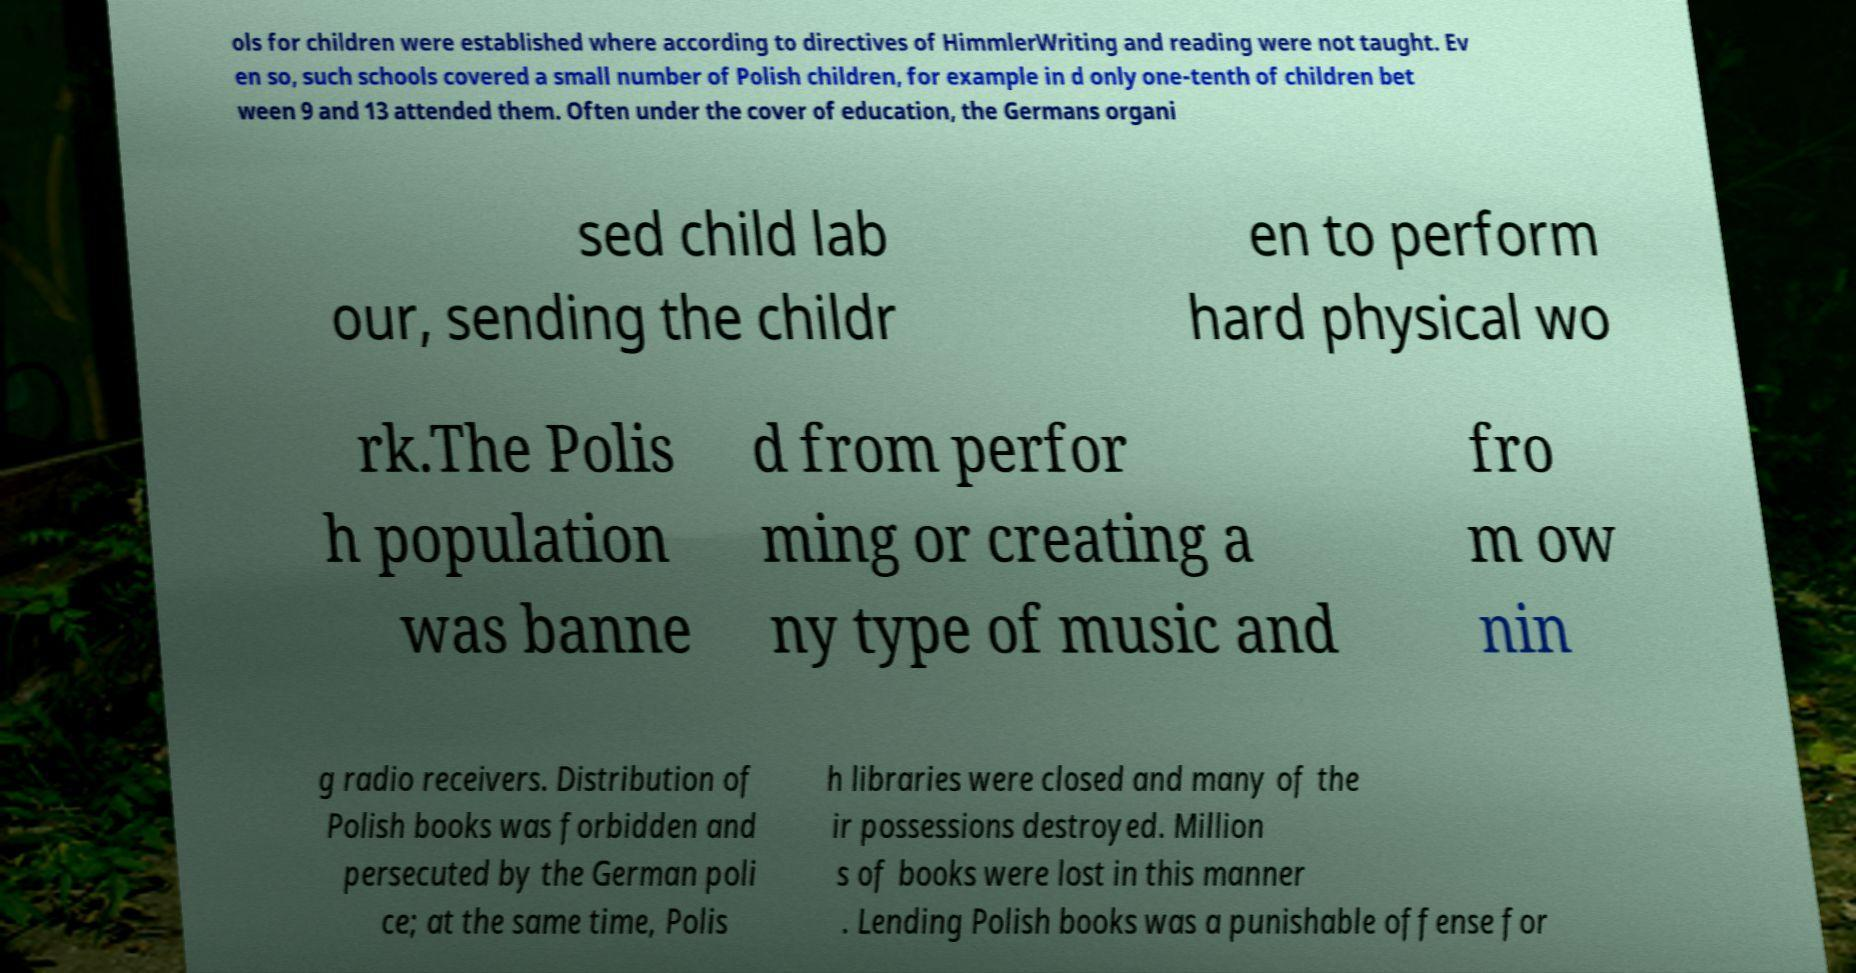Can you read and provide the text displayed in the image?This photo seems to have some interesting text. Can you extract and type it out for me? ols for children were established where according to directives of HimmlerWriting and reading were not taught. Ev en so, such schools covered a small number of Polish children, for example in d only one-tenth of children bet ween 9 and 13 attended them. Often under the cover of education, the Germans organi sed child lab our, sending the childr en to perform hard physical wo rk.The Polis h population was banne d from perfor ming or creating a ny type of music and fro m ow nin g radio receivers. Distribution of Polish books was forbidden and persecuted by the German poli ce; at the same time, Polis h libraries were closed and many of the ir possessions destroyed. Million s of books were lost in this manner . Lending Polish books was a punishable offense for 